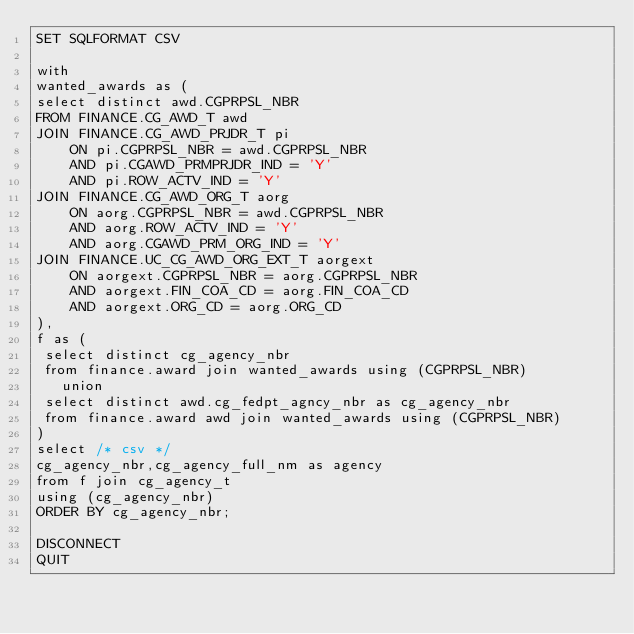Convert code to text. <code><loc_0><loc_0><loc_500><loc_500><_SQL_>SET SQLFORMAT CSV

with
wanted_awards as (
select distinct awd.CGPRPSL_NBR
FROM FINANCE.CG_AWD_T awd
JOIN FINANCE.CG_AWD_PRJDR_T pi
    ON pi.CGPRPSL_NBR = awd.CGPRPSL_NBR
    AND pi.CGAWD_PRMPRJDR_IND = 'Y'
    AND pi.ROW_ACTV_IND = 'Y'
JOIN FINANCE.CG_AWD_ORG_T aorg
    ON aorg.CGPRPSL_NBR = awd.CGPRPSL_NBR
    AND aorg.ROW_ACTV_IND = 'Y'
    AND aorg.CGAWD_PRM_ORG_IND = 'Y'
JOIN FINANCE.UC_CG_AWD_ORG_EXT_T aorgext
    ON aorgext.CGPRPSL_NBR = aorg.CGPRPSL_NBR
    AND aorgext.FIN_COA_CD = aorg.FIN_COA_CD
    AND aorgext.ORG_CD = aorg.ORG_CD
),
f as (
 select distinct cg_agency_nbr
 from finance.award join wanted_awards using (CGPRPSL_NBR)
   union
 select distinct awd.cg_fedpt_agncy_nbr as cg_agency_nbr
 from finance.award awd join wanted_awards using (CGPRPSL_NBR)
)
select /* csv */
cg_agency_nbr,cg_agency_full_nm as agency
from f join cg_agency_t
using (cg_agency_nbr)
ORDER BY cg_agency_nbr;

DISCONNECT
QUIT
</code> 